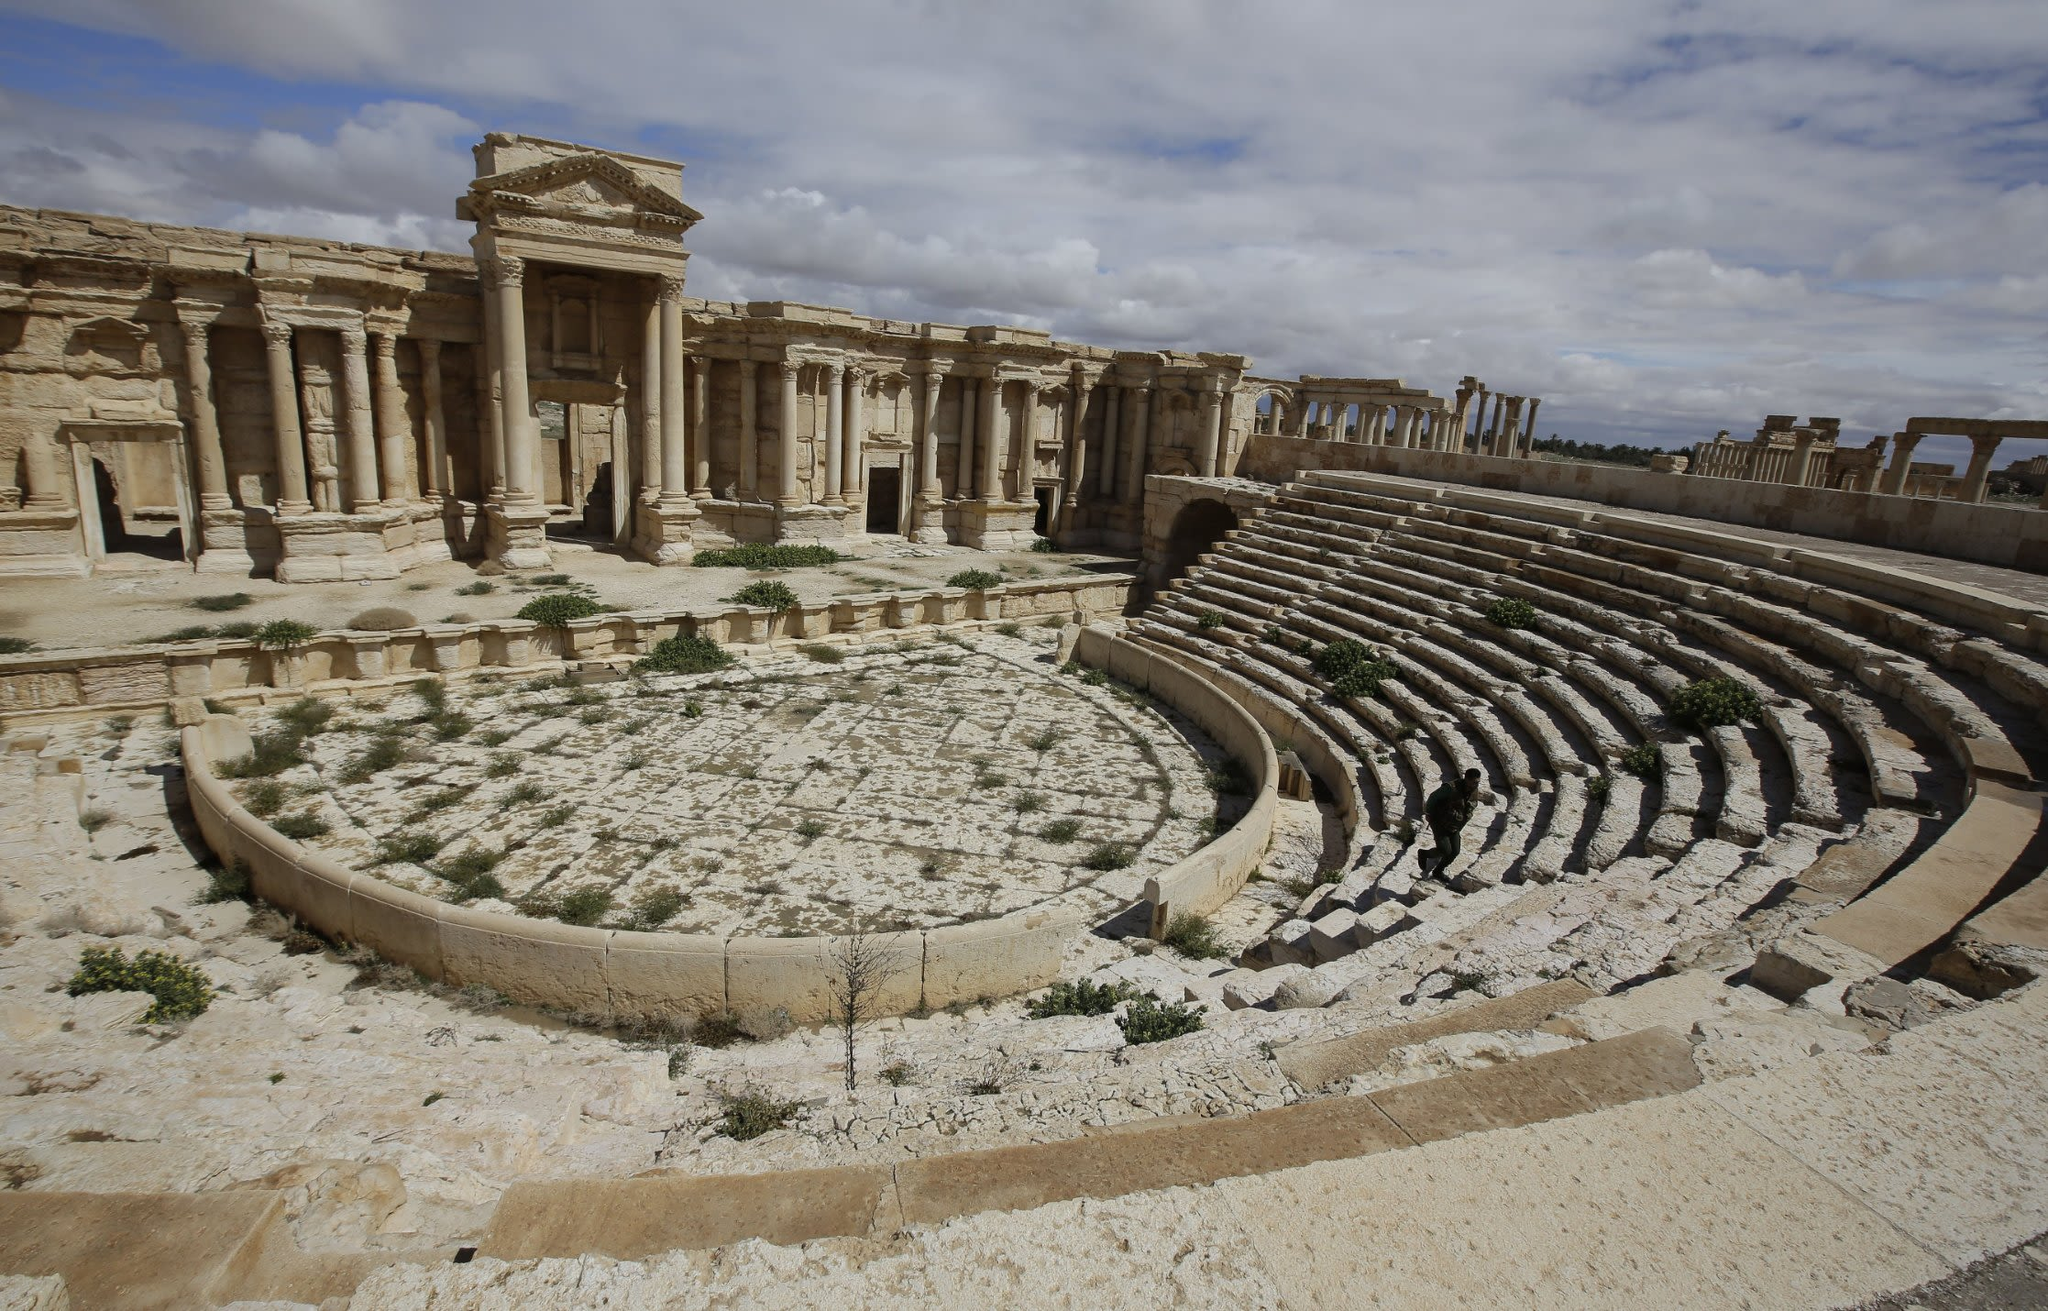Imagine an event happening in this theater during its prime. What would that be like? Imagine stepping into the theater of Palmyra during its prime. The sun is setting, casting a golden hue on the magnificent sandstone structure. The seats are filled with excited spectators from diverse backgrounds, reflecting the city's cosmopolitan nature. The air is filled with the buzzing sound of anticipation. Suddenly, the stage comes alive with actors adorned in elaborate costumes, projecting their voices to the farthest reaches of the crowd as they perform a classic Roman drama. The acoustics of the theater amplify their voices perfectly, ensuring everyone is absorbed in the tale. The aroma of exotic spices wafts through the air from the nearby market stalls, adding to the atmosphere. The event is not just a performance but a social occasion where people meet, trade, and share news, making it an integral part of the communal life in Palmyra.  If this place could talk, what stories would it tell? If the theater of Palmyra could talk, it would narrate tales of grandeur and decline. It would recount the vibrant performances that once graced its stage, from captivating dramas and thrilling gladiatorial bouts to grand parades and civic ceremonies. It would speak of the diverse crowds that flocked to its tiers, merchants, travelers, and residents, bringing life and diversity to the city center. The theater would tell stories of love, war, and politics that unfurled before its gaze, offering a window into the cultural melting pot that Palmyra was. It would mourn the moments of conflict and ruin that marred its structure, yet also celebrate the enduring spirit of resilience and history that it represents. Through its eroded stone and silent seats, it would convey a dramatic chronicle of human creativity, community, and endurance. 